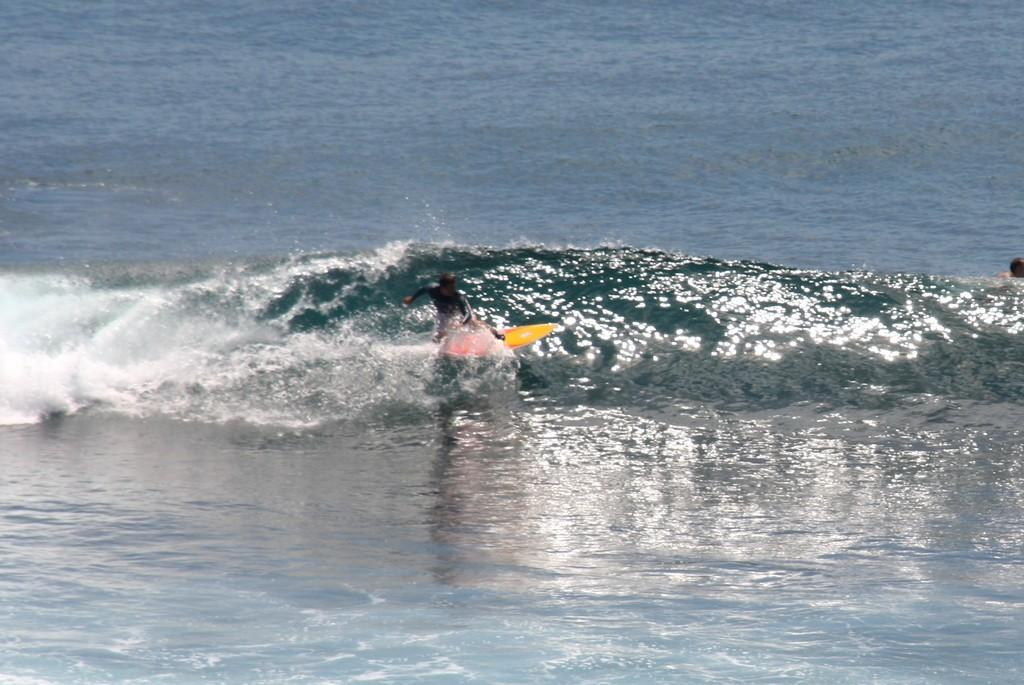What is the man in the image doing? The man is on a surfing board in the image. Where is the second man located in the image? There is a man towards the right side of the image. What is the primary setting of the image? There is water visible in the image. What can be seen in the water in the image? There is a water wave in the image. What type of mitten is the man wearing while surfing in the image? There is no mitten present in the image; the man is on a surfing board in the water. How many trains can be seen in the image? There are no trains present in the image. 